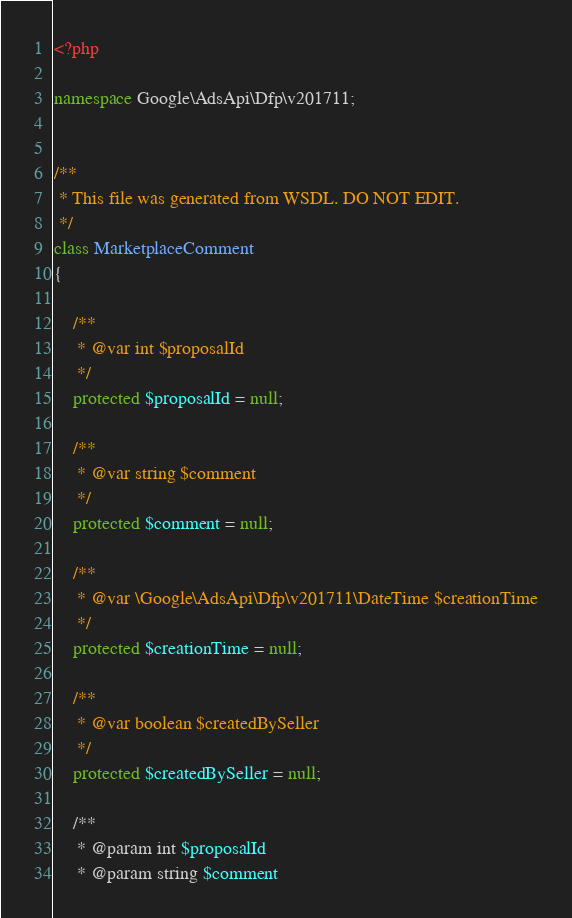<code> <loc_0><loc_0><loc_500><loc_500><_PHP_><?php

namespace Google\AdsApi\Dfp\v201711;


/**
 * This file was generated from WSDL. DO NOT EDIT.
 */
class MarketplaceComment
{

    /**
     * @var int $proposalId
     */
    protected $proposalId = null;

    /**
     * @var string $comment
     */
    protected $comment = null;

    /**
     * @var \Google\AdsApi\Dfp\v201711\DateTime $creationTime
     */
    protected $creationTime = null;

    /**
     * @var boolean $createdBySeller
     */
    protected $createdBySeller = null;

    /**
     * @param int $proposalId
     * @param string $comment</code> 